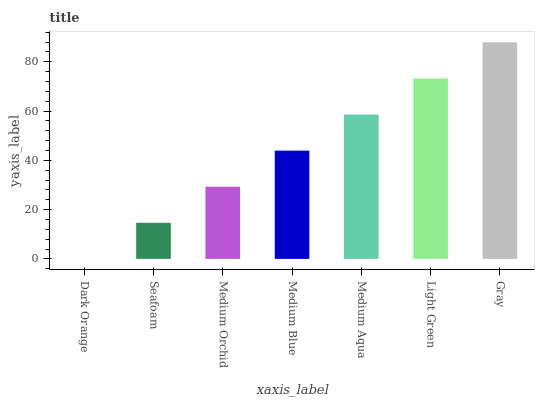Is Dark Orange the minimum?
Answer yes or no. Yes. Is Gray the maximum?
Answer yes or no. Yes. Is Seafoam the minimum?
Answer yes or no. No. Is Seafoam the maximum?
Answer yes or no. No. Is Seafoam greater than Dark Orange?
Answer yes or no. Yes. Is Dark Orange less than Seafoam?
Answer yes or no. Yes. Is Dark Orange greater than Seafoam?
Answer yes or no. No. Is Seafoam less than Dark Orange?
Answer yes or no. No. Is Medium Blue the high median?
Answer yes or no. Yes. Is Medium Blue the low median?
Answer yes or no. Yes. Is Light Green the high median?
Answer yes or no. No. Is Medium Aqua the low median?
Answer yes or no. No. 